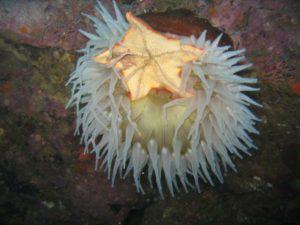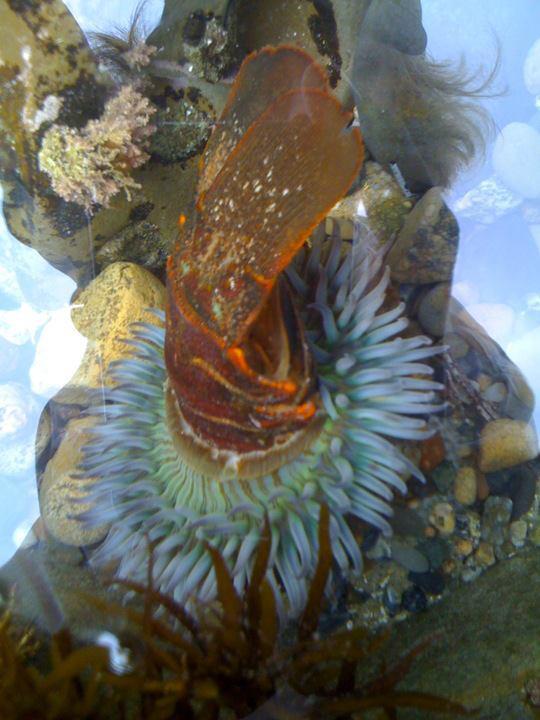The first image is the image on the left, the second image is the image on the right. Examine the images to the left and right. Is the description "There is a crab inside an anemone." accurate? Answer yes or no. No. The first image is the image on the left, the second image is the image on the right. Analyze the images presented: Is the assertion "An image shows multiple fish with yellow coloration swimming near a large anemone." valid? Answer yes or no. No. 